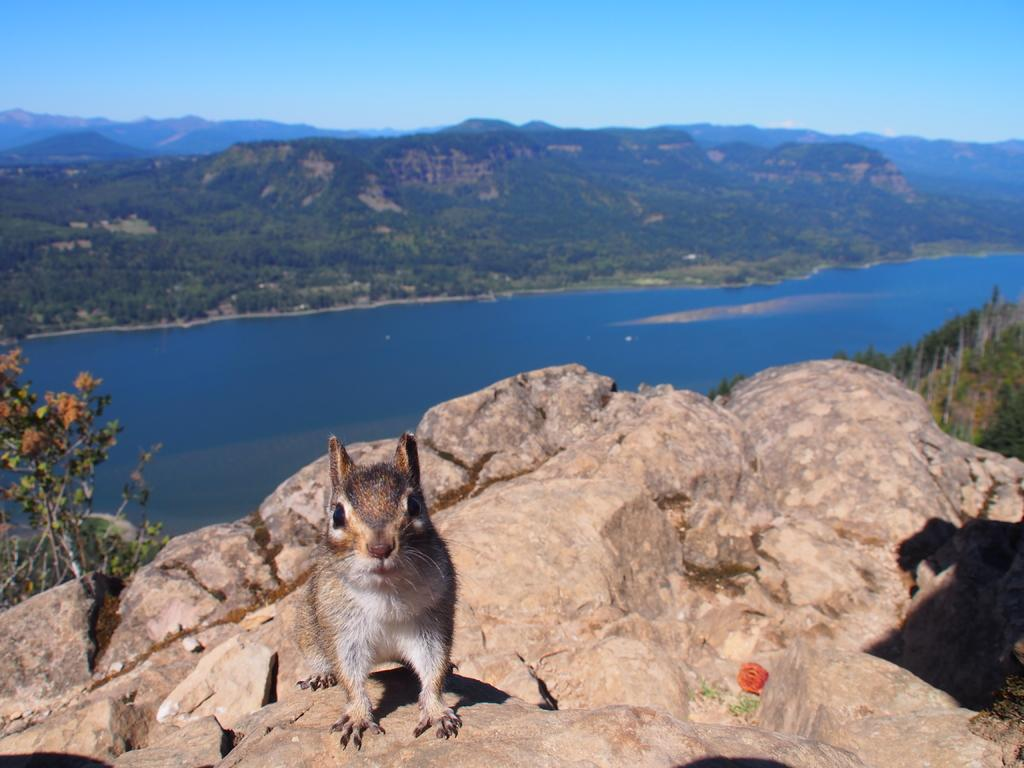What type of terrain is featured in the image? There is a rock hill in the image. What is on top of the rock hill? There is an animal standing on the rock hill. What is located behind the rock hill? There is a river behind the rock hill. What can be seen beyond the river? There is a lot of greenery behind the river. Where is the boot hanging on the rock hill in the image? There is no boot present in the image; it only features a rock hill, an animal, a river, and greenery. 